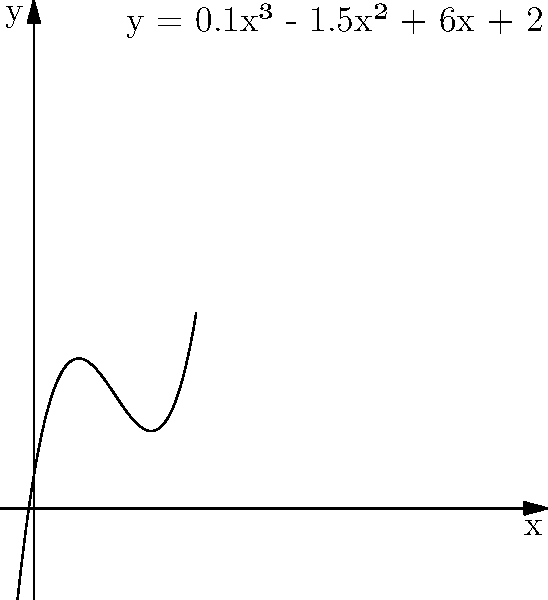As an animal rights advocate, you've been tracking the number of rescued circus animals over time. The growth can be modeled by the cubic function $y = 0.1x^3 - 1.5x^2 + 6x + 2$, where $x$ represents the number of months since you started your advocacy work, and $y$ represents the number of rescued animals. At what month does the rate of animal rescues start to increase again after an initial slowdown? To find when the rate of animal rescues starts to increase again, we need to find the inflection point of the cubic function. Here's how:

1) The rate of change is represented by the first derivative:
   $f'(x) = 0.3x^2 - 3x + 6$

2) The change in the rate of change is represented by the second derivative:
   $f''(x) = 0.6x - 3$

3) The inflection point occurs when the second derivative equals zero:
   $0.6x - 3 = 0$
   $0.6x = 3$
   $x = 5$

4) To confirm this is a point where the rate starts increasing again, we can check the sign of $f''(x)$ before and after $x=5$:
   At $x=4$: $f''(4) = 0.6(4) - 3 = -0.6$ (negative)
   At $x=6$: $f''(6) = 0.6(6) - 3 = 0.6$ (positive)

5) The change from negative to positive confirms that the rate starts increasing again at $x=5$.

Therefore, the rate of animal rescues starts to increase again after an initial slowdown at 5 months.
Answer: 5 months 